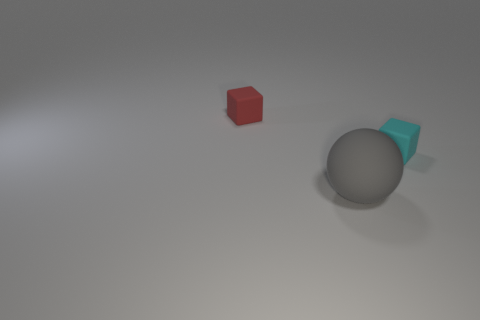Is the number of big matte spheres to the left of the small red matte thing less than the number of rubber balls that are behind the big sphere? In the image, there is one large matte sphere to the left of the small red cube. There are no rubber balls visible in the scene, therefore it's not possible to confirm the presence or count of rubber balls behind the big sphere. Based on what can be seen, we can only discuss the objects that are visible. The count of big matte spheres is one, and since we do not see any rubber balls, we cannot say that there are more rubber balls than the one matte sphere. 